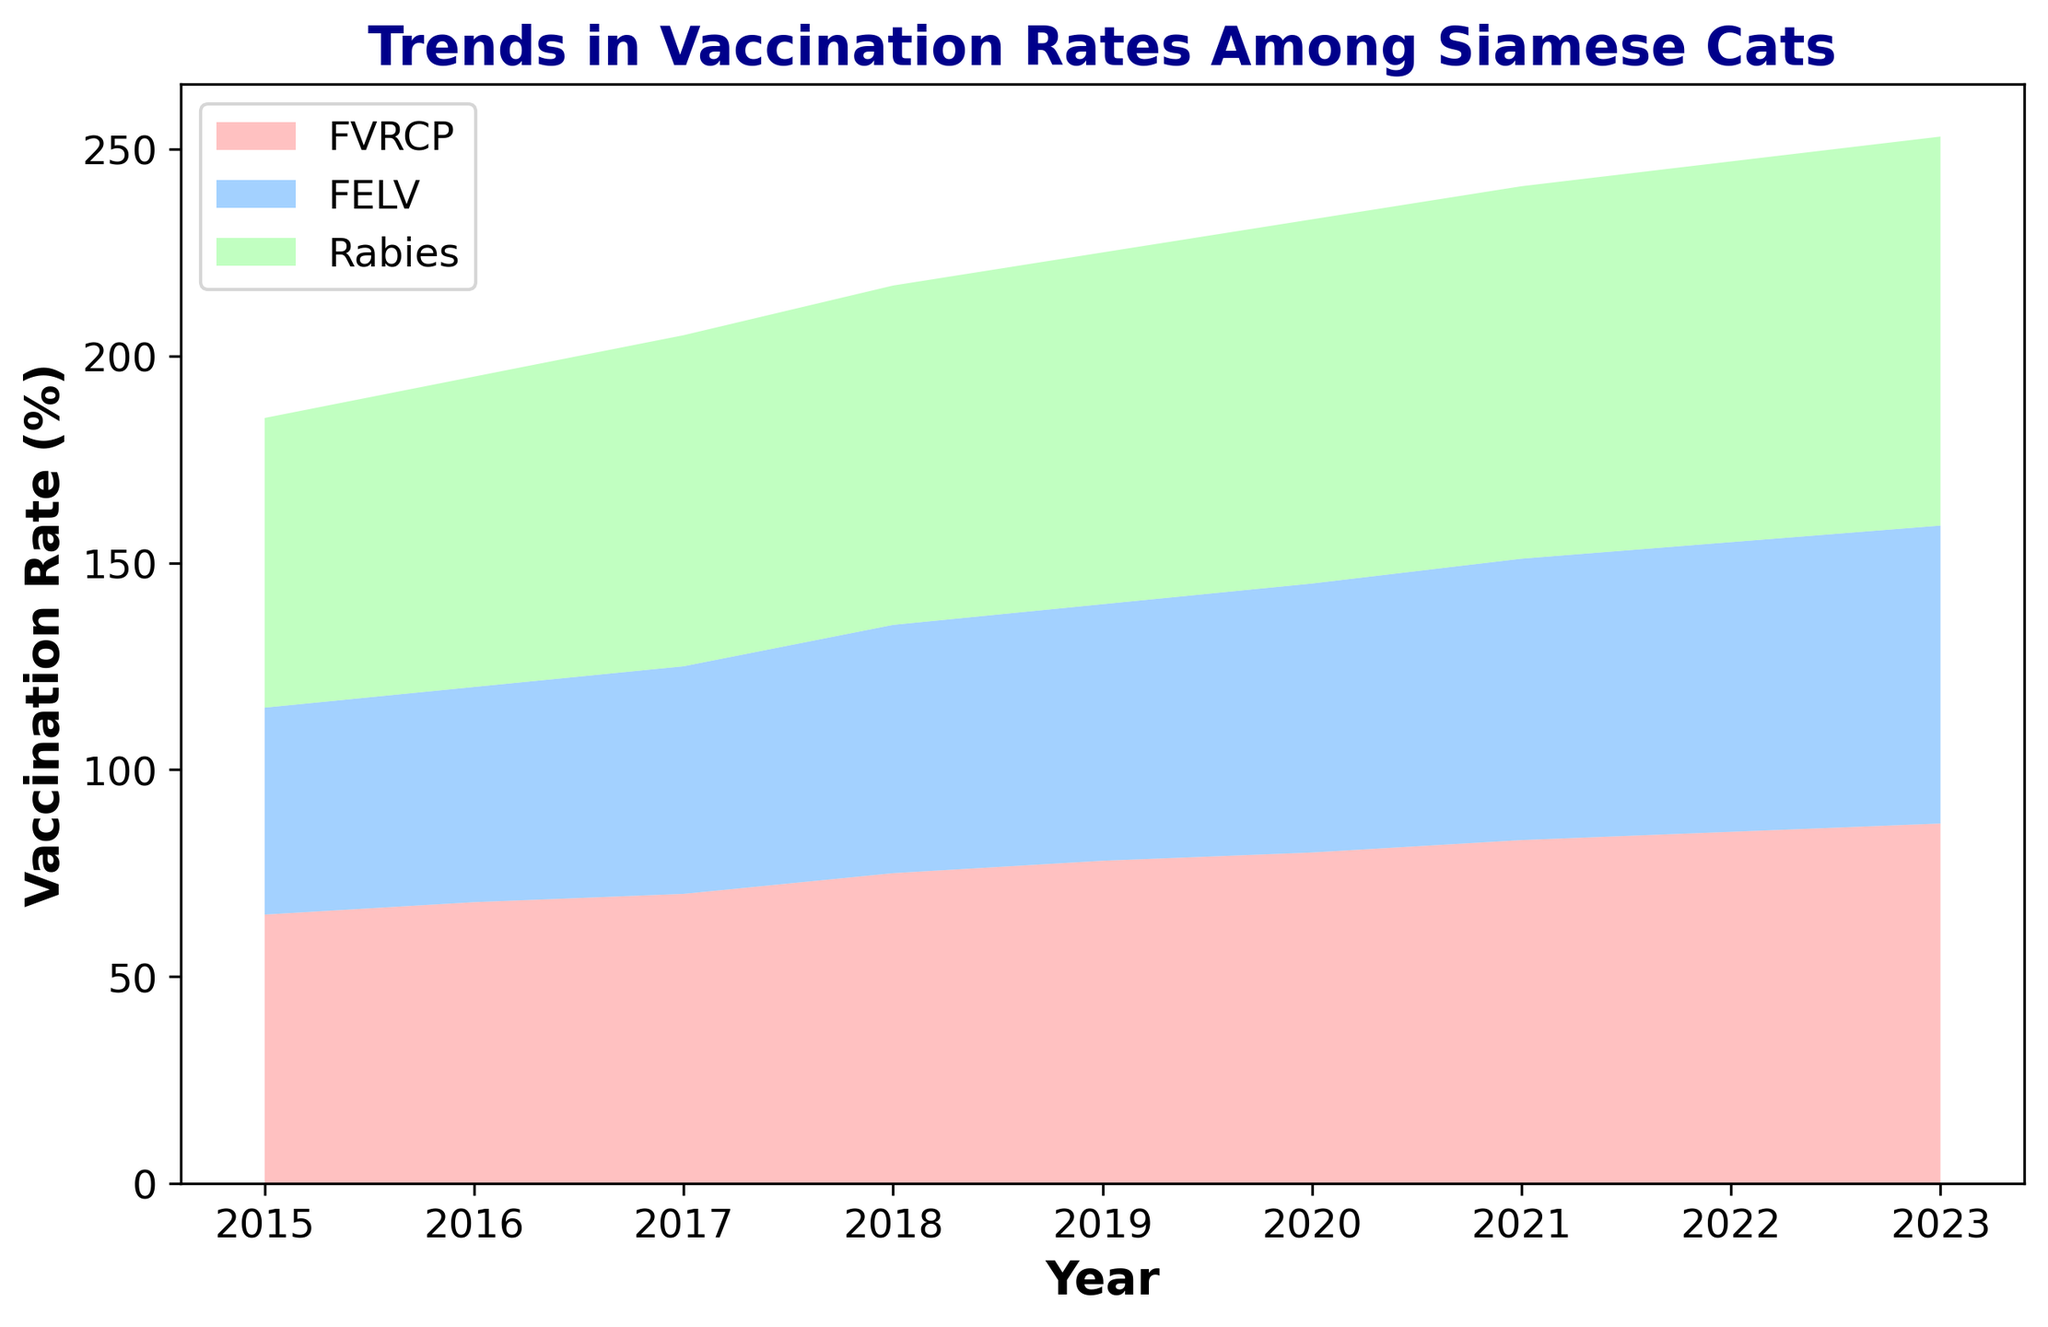What year did the vaccination rate for FELV surpass 60%? To find the year when FELV vaccination rate surpassed 60%, look at the FELV values and check for the first year that exceeds 60%. This value first appears in 2018.
Answer: 2018 In which year was the increase in FVRCP vaccination rate the highest compared to the previous year? To determine the year with the highest increase in FVRCP vaccination, calculate the annual differences and identify the maximum. The increases are: 2016-2015 (3), 2017-2016 (2), 2018-2017 (5), 2019-2018 (3), 2020-2019 (2), 2021-2020 (3), 2022-2021 (2), and 2023-2022 (2). The largest increase is from 2017 to 2018.
Answer: 2018 What is the combined vaccination rate for all three vaccines in 2020? Sum the vaccination rates for FVRCP (80%), FELV (65%), and Rabies (88%) in the year 2020: 80 + 65 + 88 = 233.
Answer: 233 Which vaccine shows the smallest increase in vaccination rates from 2015 to 2023? To find this, compare the total increase for each vaccine: FVRCP (87-65=22), FELV (72-50=22), Rabies (94-70=24). Both FVRCP and FELV have the smallest increase of 22.
Answer: FVRCP and FELV How do the vaccination rates for FVRCP and Rabies compare in 2021? Check both values for the year 2021: FVRCP (83%) and Rabies (90%). Rabies has a higher rate than FVRCP.
Answer: Rabies is higher What is the total vaccination rate for FVRCP over the entire period from 2015 to 2023? Sum the FVRCP rates from all years: 65 + 68 + 70 + 75 + 78 + 80 + 83 + 85 + 87 = 691.
Answer: 691 How much did the vaccination rate for Rabies increase from 2017 to 2018? Subtract the Rabies vaccination rate in 2017 from that in 2018: 82 - 80 = 2.
Answer: 2 Which two consecutive years show the smallest percentage increase in FELV vaccination rates? Calculate the yearly increases for FELV, then identify the smallest: 2016-2015 (2), 2017-2016 (3), 2018-2017 (5), 2019-2018 (2), 2020-2019 (3), 2021-2020 (3), 2022-2021 (2), 2023-2022 (2). The smallest increase happens both 2019-2018 and 2022-2021 and 2023-2022, a 2% increase.
Answer: 2019-2018 and 2022-2021 and 2023-2022 What color represents FVRCP in the chart? Identify the color used in the area chart for FVRCP. FVRCP is represented by red.
Answer: Red 